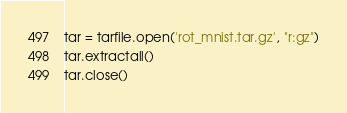<code> <loc_0><loc_0><loc_500><loc_500><_Python_>
tar = tarfile.open('rot_mnist.tar.gz', "r:gz")
tar.extractall()
tar.close()
</code> 